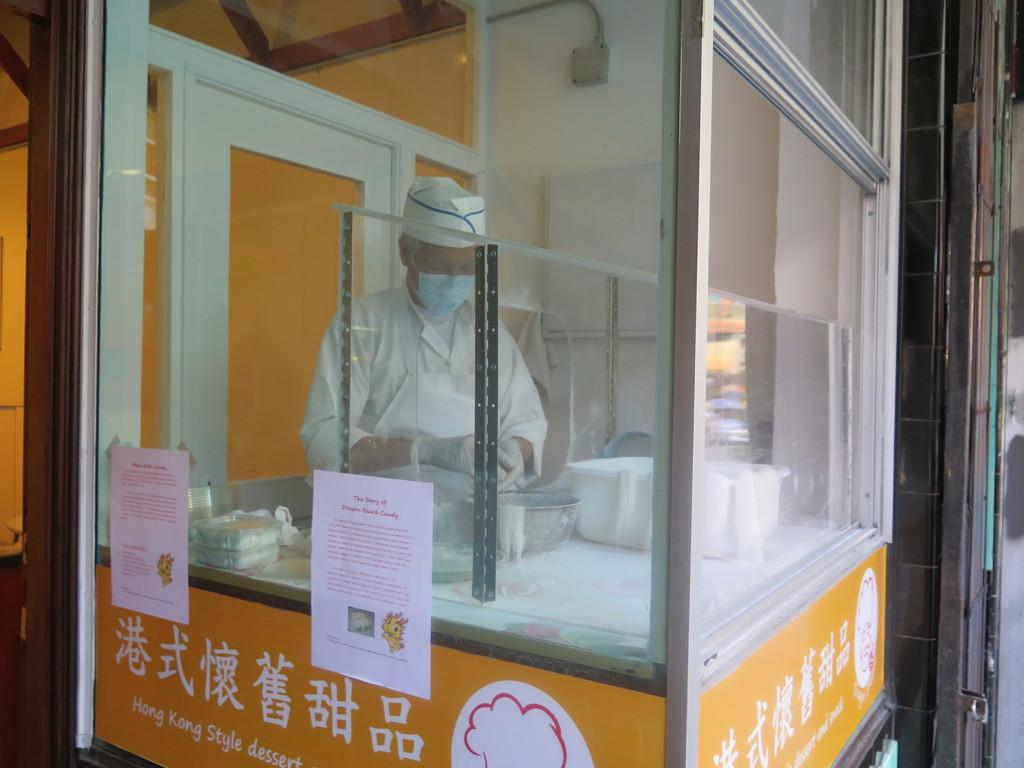What is the man in the image doing? The man is standing in the image. Can you describe what the man is wearing on his face? The man is wearing a mask on his mouth. What object can be seen on a table in the image? There is a bowl on a table in the image. What is the purpose of the papers in the image? The papers are pasted on a glass in the image. How many oranges are being held by the fairies in the image? There are no oranges or fairies present in the image. 